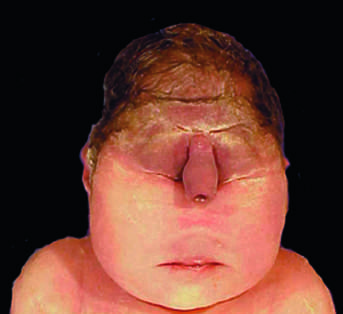re the midface structures fused or ill-formed?
Answer the question using a single word or phrase. Yes 